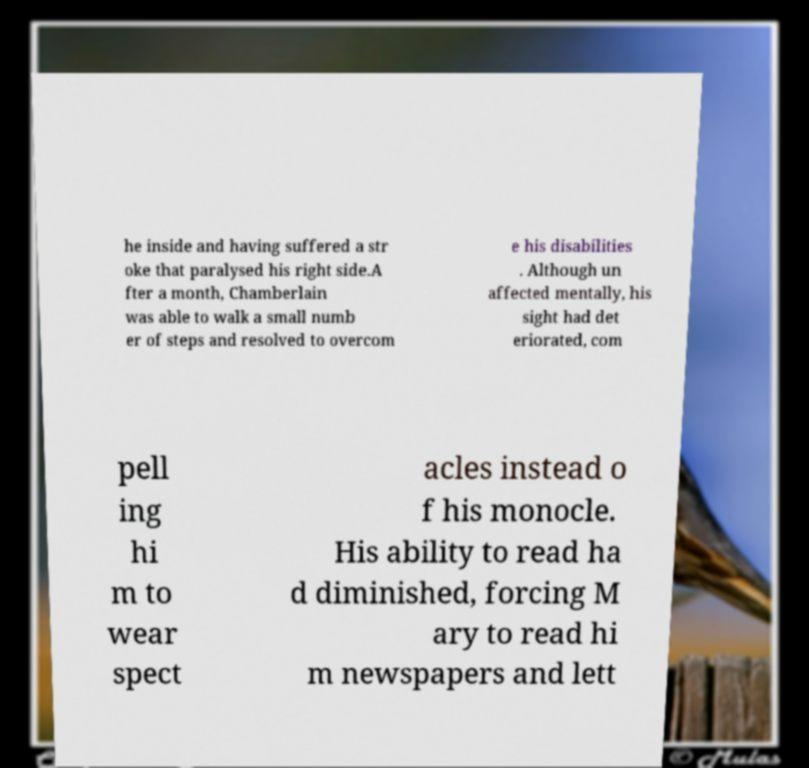Please read and relay the text visible in this image. What does it say? he inside and having suffered a str oke that paralysed his right side.A fter a month, Chamberlain was able to walk a small numb er of steps and resolved to overcom e his disabilities . Although un affected mentally, his sight had det eriorated, com pell ing hi m to wear spect acles instead o f his monocle. His ability to read ha d diminished, forcing M ary to read hi m newspapers and lett 